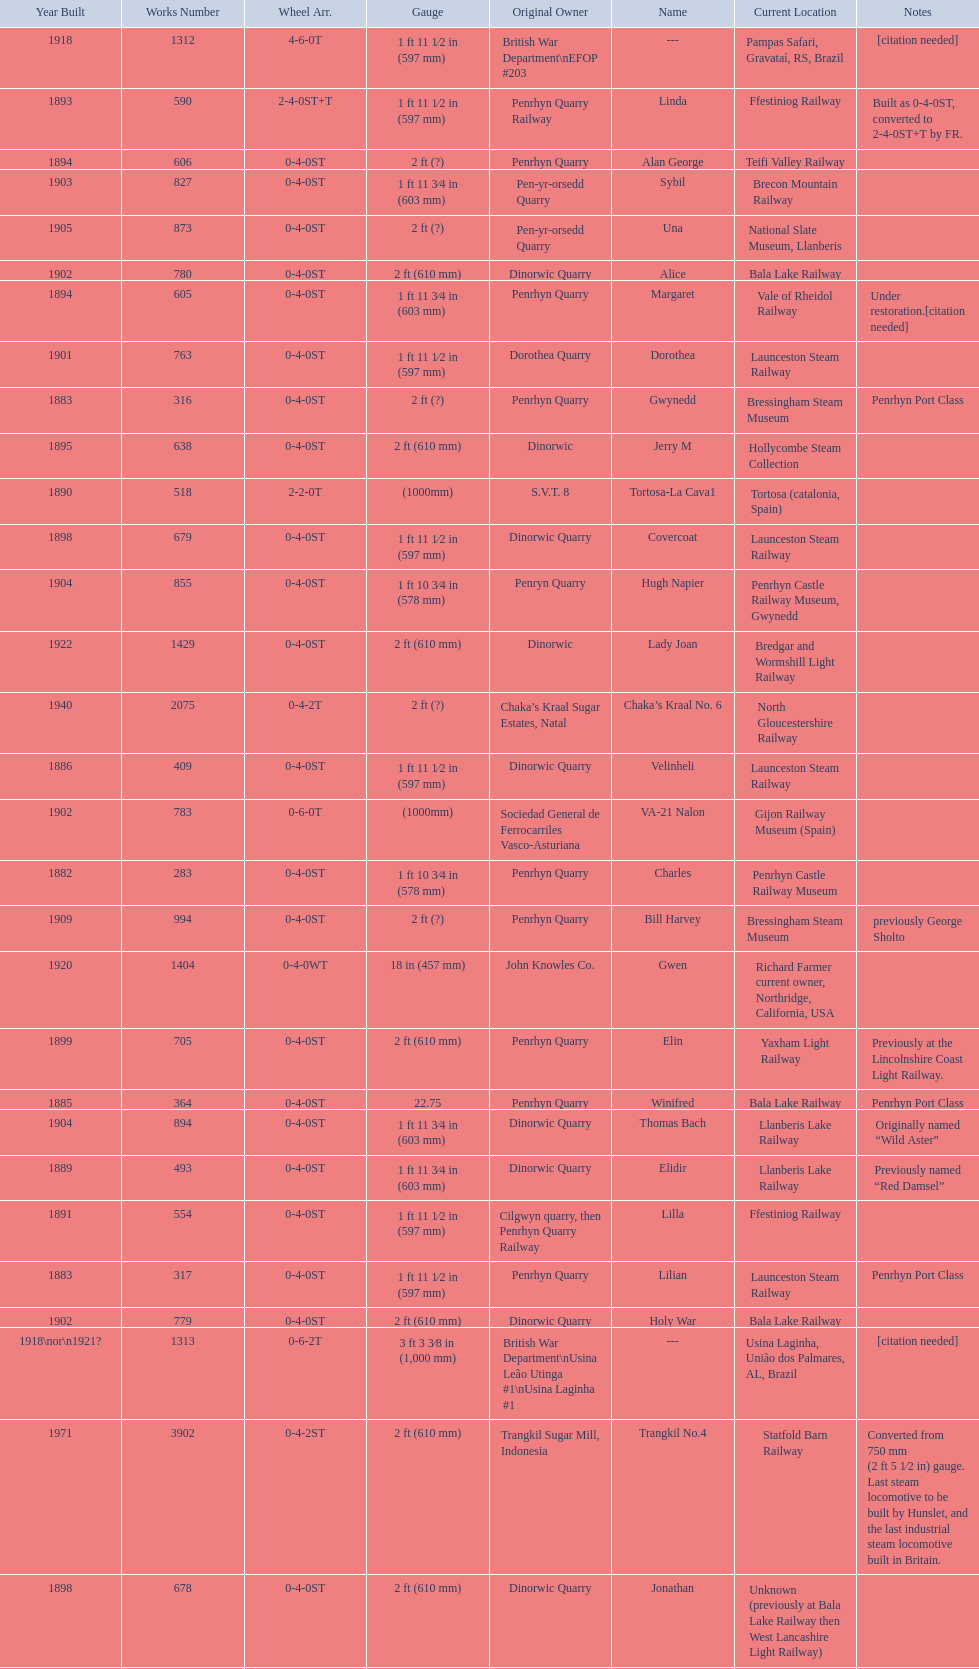In which year were the most steam locomotives built? 1898. 